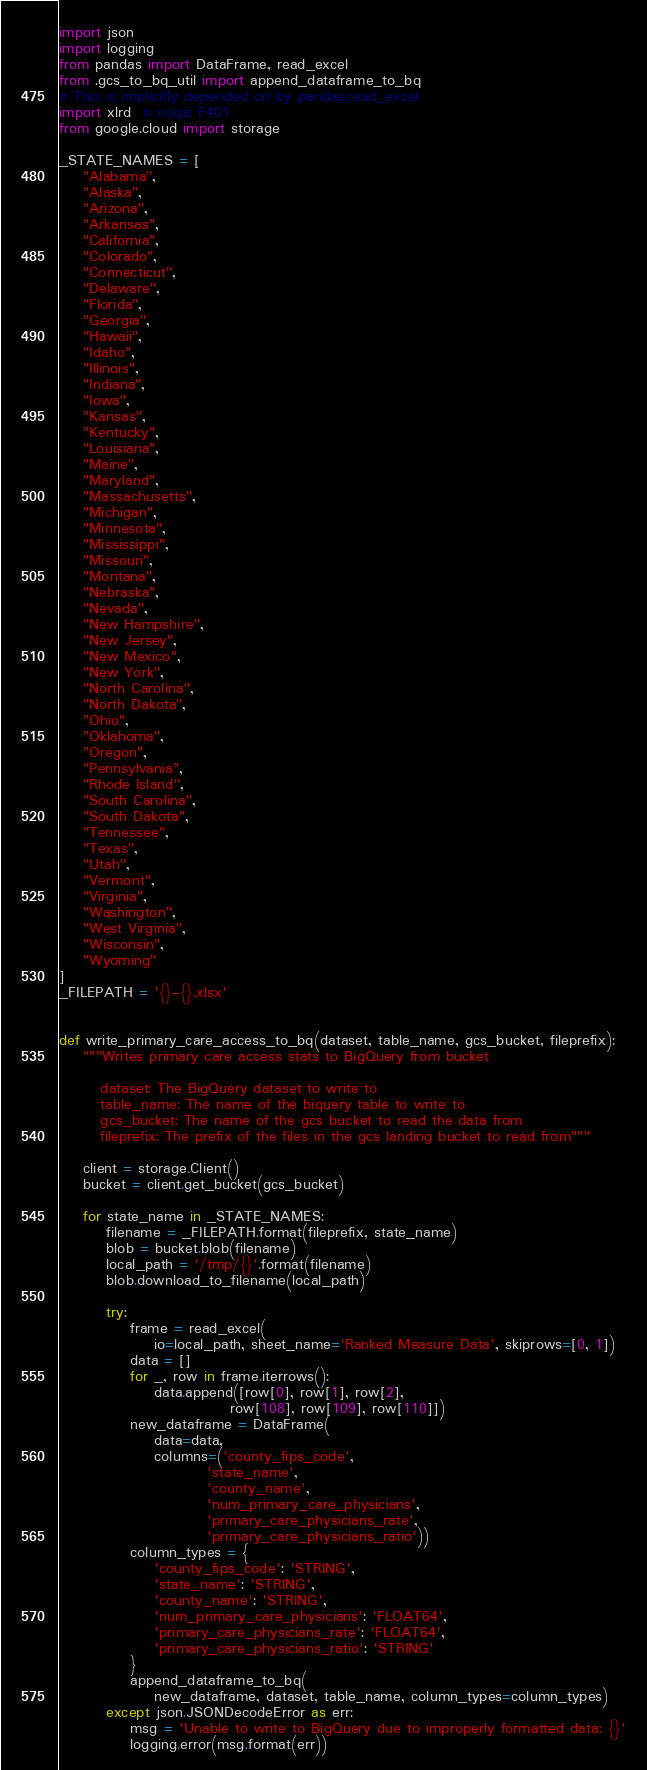<code> <loc_0><loc_0><loc_500><loc_500><_Python_>import json
import logging
from pandas import DataFrame, read_excel
from .gcs_to_bq_util import append_dataframe_to_bq
# This is implicitly depended on by pandas.read_excel
import xlrd  # noqa: F401
from google.cloud import storage

_STATE_NAMES = [
    "Alabama",
    "Alaska",
    "Arizona",
    "Arkansas",
    "California",
    "Colorado",
    "Connecticut",
    "Delaware",
    "Florida",
    "Georgia",
    "Hawaii",
    "Idaho",
    "Illinois",
    "Indiana",
    "Iowa",
    "Kansas",
    "Kentucky",
    "Louisiana",
    "Maine",
    "Maryland",
    "Massachusetts",
    "Michigan",
    "Minnesota",
    "Mississippi",
    "Missouri",
    "Montana",
    "Nebraska",
    "Nevada",
    "New Hampshire",
    "New Jersey",
    "New Mexico",
    "New York",
    "North Carolina",
    "North Dakota",
    "Ohio",
    "Oklahoma",
    "Oregon",
    "Pennsylvania",
    "Rhode Island",
    "South Carolina",
    "South Dakota",
    "Tennessee",
    "Texas",
    "Utah",
    "Vermont",
    "Virginia",
    "Washington",
    "West Virginia",
    "Wisconsin",
    "Wyoming"
]
_FILEPATH = '{}-{}.xlsx'


def write_primary_care_access_to_bq(dataset, table_name, gcs_bucket, fileprefix):
    """Writes primary care access stats to BigQuery from bucket

       dataset: The BigQuery dataset to write to
       table_name: The name of the biquery table to write to
       gcs_bucket: The name of the gcs bucket to read the data from
       fileprefix: The prefix of the files in the gcs landing bucket to read from"""

    client = storage.Client()
    bucket = client.get_bucket(gcs_bucket)

    for state_name in _STATE_NAMES:
        filename = _FILEPATH.format(fileprefix, state_name)
        blob = bucket.blob(filename)
        local_path = '/tmp/{}'.format(filename)
        blob.download_to_filename(local_path)

        try:
            frame = read_excel(
                io=local_path, sheet_name='Ranked Measure Data', skiprows=[0, 1])
            data = []
            for _, row in frame.iterrows():
                data.append([row[0], row[1], row[2],
                             row[108], row[109], row[110]])
            new_dataframe = DataFrame(
                data=data,
                columns=('county_fips_code',
                         'state_name',
                         'county_name',
                         'num_primary_care_physicians',
                         'primary_care_physicians_rate',
                         'primary_care_physicians_ratio'))
            column_types = {
                'county_fips_code': 'STRING',
                'state_name': 'STRING',
                'county_name': 'STRING',
                'num_primary_care_physicians': 'FLOAT64',
                'primary_care_physicians_rate': 'FLOAT64',
                'primary_care_physicians_ratio': 'STRING'
            }
            append_dataframe_to_bq(
                new_dataframe, dataset, table_name, column_types=column_types)
        except json.JSONDecodeError as err:
            msg = 'Unable to write to BigQuery due to improperly formatted data: {}'
            logging.error(msg.format(err))
</code> 